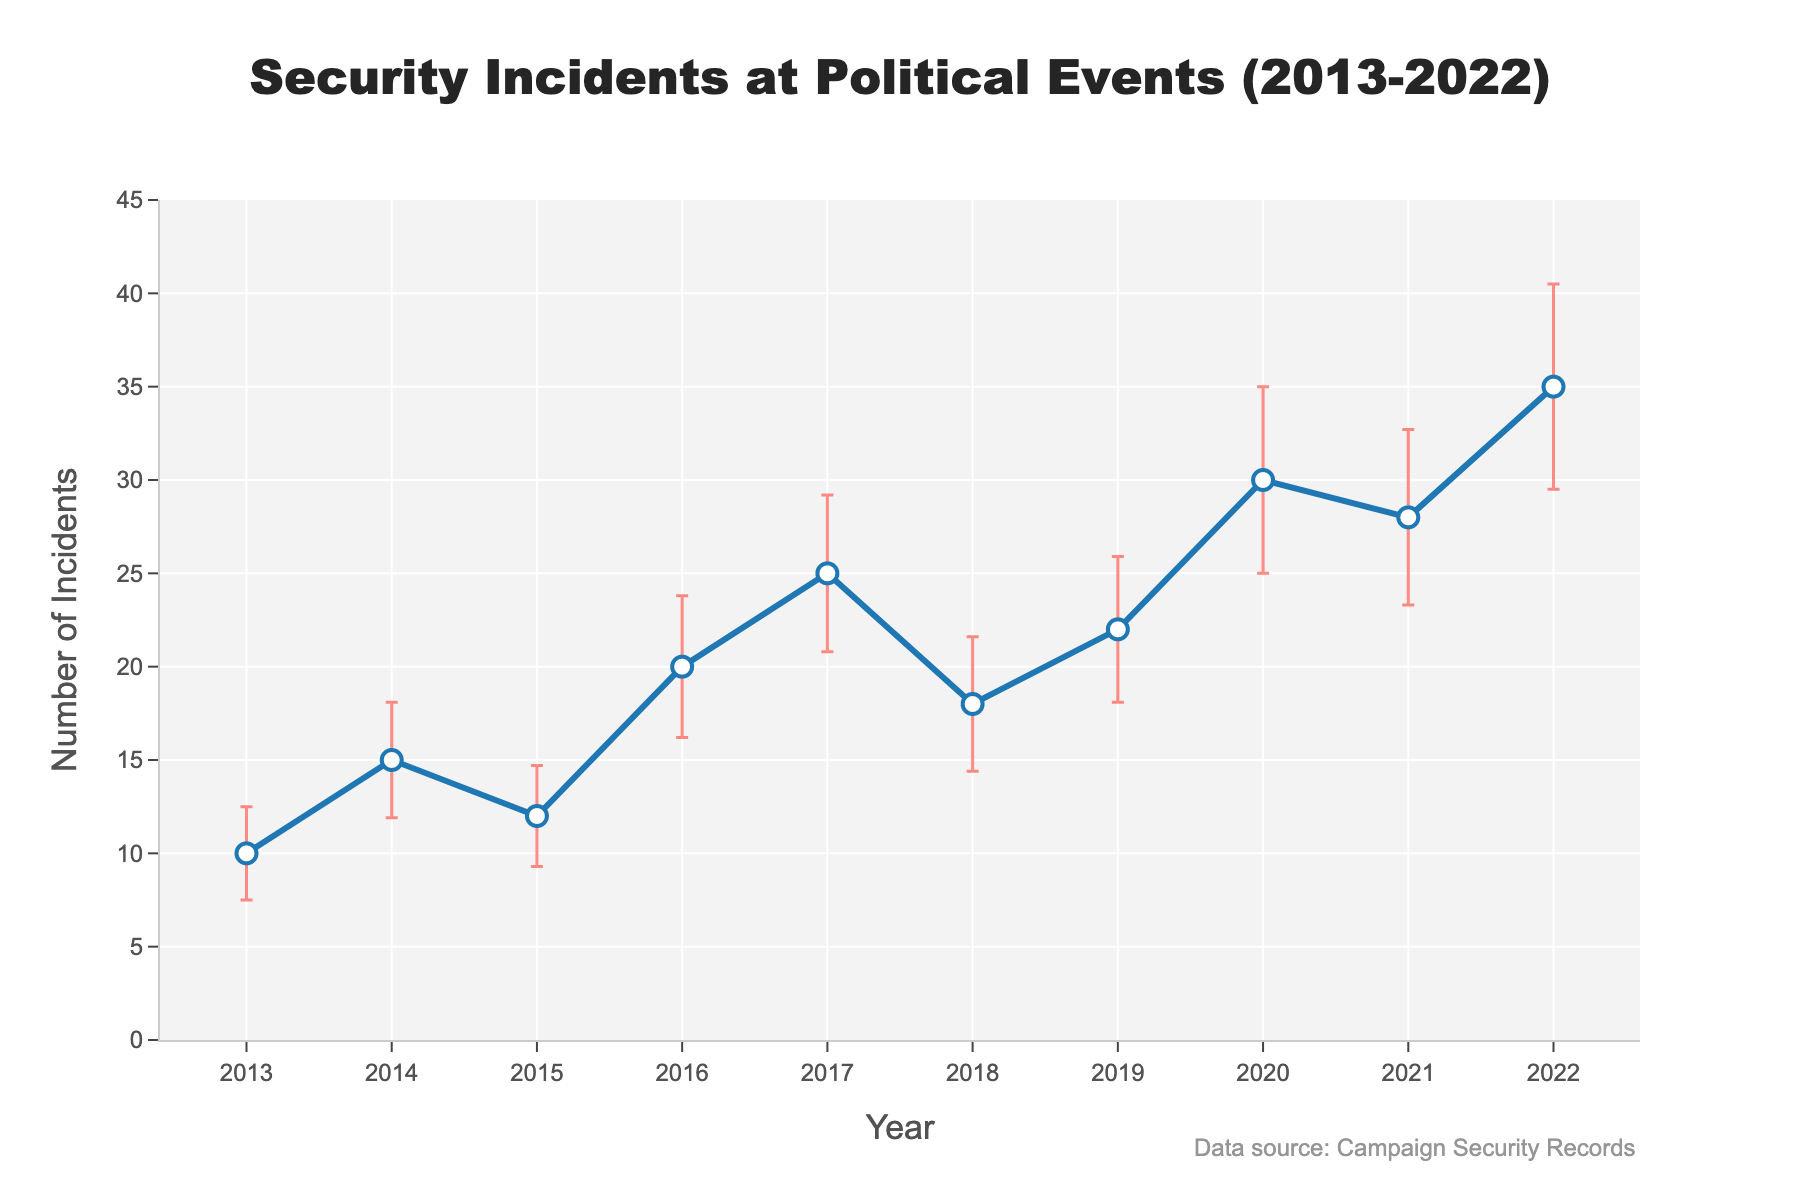What is the title of the plot? The title is visually located at the top center of the plot in larger font size. It provides information about the subject of the plot over a specific time period.
Answer: Security Incidents at Political Events (2013-2022) What is the value of the number of incidents in 2017? The y-axis value for the year 2017 intersects at a specific point on the line plot.
Answer: 25 What is the highest number of incidents recorded in the given years? By looking at the highest point on the line plot along the y-axis, we find the maximum value recorded.
Answer: 35 How does the number of incidents in 2019 compare to 2015? Locate the y-axis values for the years 2019 and 2015 and compare them directly.
Answer: 2019 has more incidents (22) compared to 2015 (12) What is the average number of incidents from 2013 to 2016? Sum up the number of incidents from 2013 to 2016 and divide by the number of years (4): (10+15+12+20) / 4 = 57 / 4 = 14.25
Answer: 14.25 Which year has the largest standard deviation, and what is its value? Look for the year with the largest error bar, which visually represents the standard deviation, and read the value.
Answer: 2022, 5.5 What is the overall trend in the number of incidents from 2018 to 2022? Observe the line plot from 2018 and follow it to 2022 to see if it is increasing, decreasing, or stable.
Answer: Increasing What is the difference in the number of incidents between 2014 and 2020? Subtract the number of incidents in 2014 from those in 2020: 30 - 15 = 15
Answer: 15 How many data points are shown in the plot? Count the number of markers along the line plot. Each represents a data point for each year from 2013 to 2022.
Answer: 10 Which years have a number of incidents within one standard deviation from the mean number of incidents? First, calculate the mean of the incidents: (10 + 15 + 12 + 20 + 25 + 18 + 22 + 30 + 28 + 35) / 10 = 21.5. 
   Then check if the value falls within mean ± standard deviation for each year. 
   Only include the years where mean - SD <= Number of Incidents <= mean + SD. 
   Mean - SD = 21.5 - 5 = 16.5, Mean + SD = 21.5 + 5 = 26.5 (consider approximate guesstimates for standard deviation ranges)
   Verify each year if it’s within this range.
Answer: 2016, 2017, 2018, 2019, 2020 